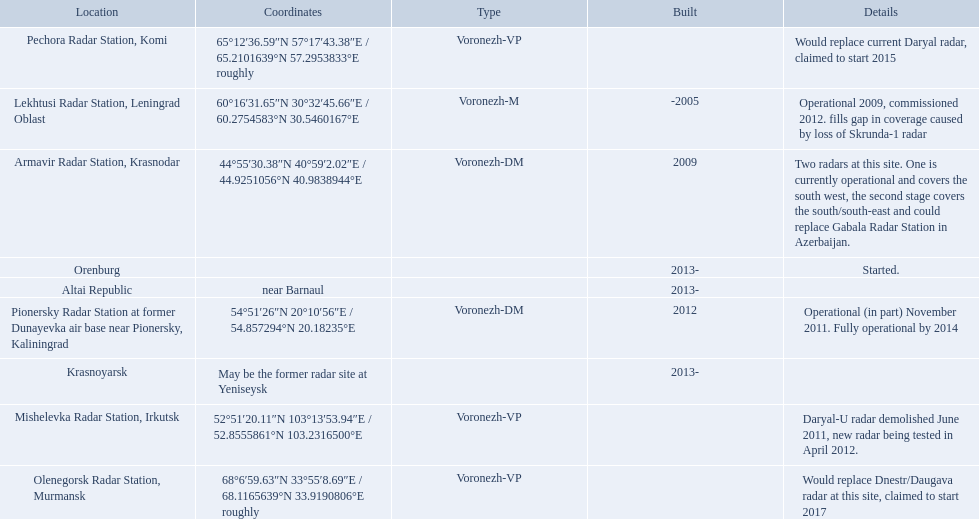Which column has the coordinates starting with 60 deg? 60°16′31.65″N 30°32′45.66″E﻿ / ﻿60.2754583°N 30.5460167°E. What is the location in the same row as that column? Lekhtusi Radar Station, Leningrad Oblast. What are the list of radar locations? Lekhtusi Radar Station, Leningrad Oblast, Armavir Radar Station, Krasnodar, Pionersky Radar Station at former Dunayevka air base near Pionersky, Kaliningrad, Mishelevka Radar Station, Irkutsk, Pechora Radar Station, Komi, Olenegorsk Radar Station, Murmansk, Krasnoyarsk, Altai Republic, Orenburg. Which of these are claimed to start in 2015? Pechora Radar Station, Komi. Voronezh radar has locations where? Lekhtusi Radar Station, Leningrad Oblast, Armavir Radar Station, Krasnodar, Pionersky Radar Station at former Dunayevka air base near Pionersky, Kaliningrad, Mishelevka Radar Station, Irkutsk, Pechora Radar Station, Komi, Olenegorsk Radar Station, Murmansk, Krasnoyarsk, Altai Republic, Orenburg. Which of these locations have know coordinates? Lekhtusi Radar Station, Leningrad Oblast, Armavir Radar Station, Krasnodar, Pionersky Radar Station at former Dunayevka air base near Pionersky, Kaliningrad, Mishelevka Radar Station, Irkutsk, Pechora Radar Station, Komi, Olenegorsk Radar Station, Murmansk. Which of these locations has coordinates of 60deg16'31.65''n 30deg32'45.66''e / 60.2754583degn 30.5460167dege? Lekhtusi Radar Station, Leningrad Oblast. 